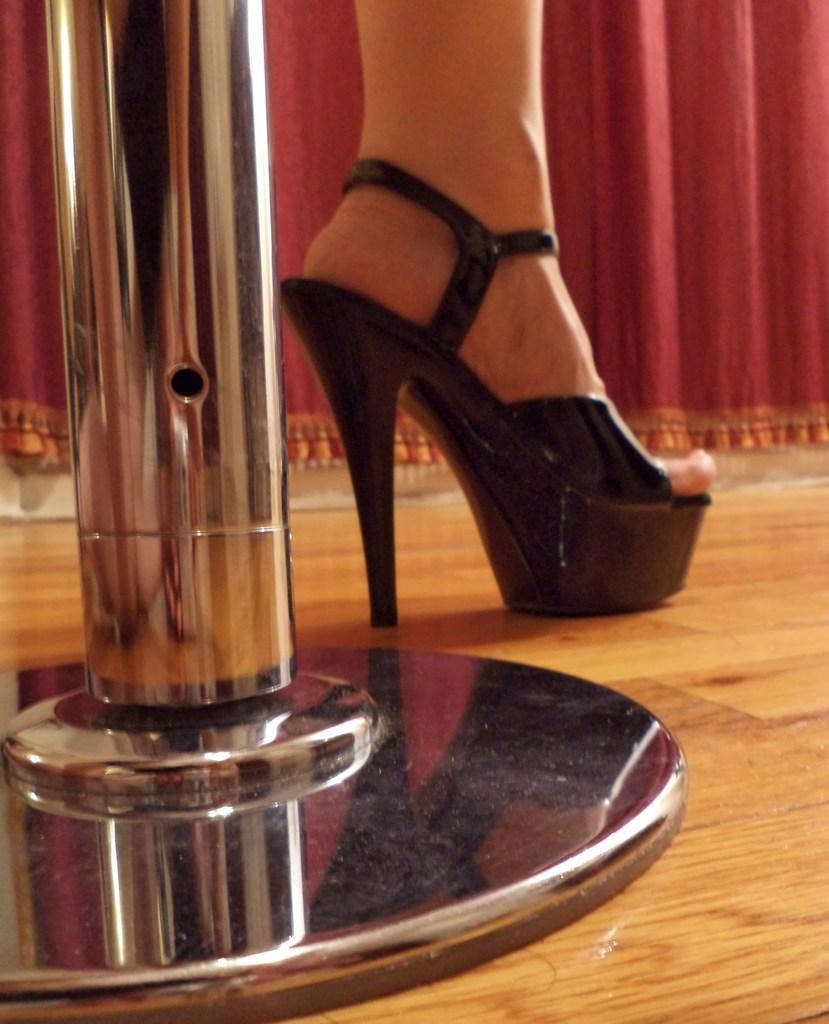Can you describe this image briefly? In this image we can see a woman's leg with shoe placed on the ground. To the left side of the image we can see a pole. In the background, we can see a curtain. 